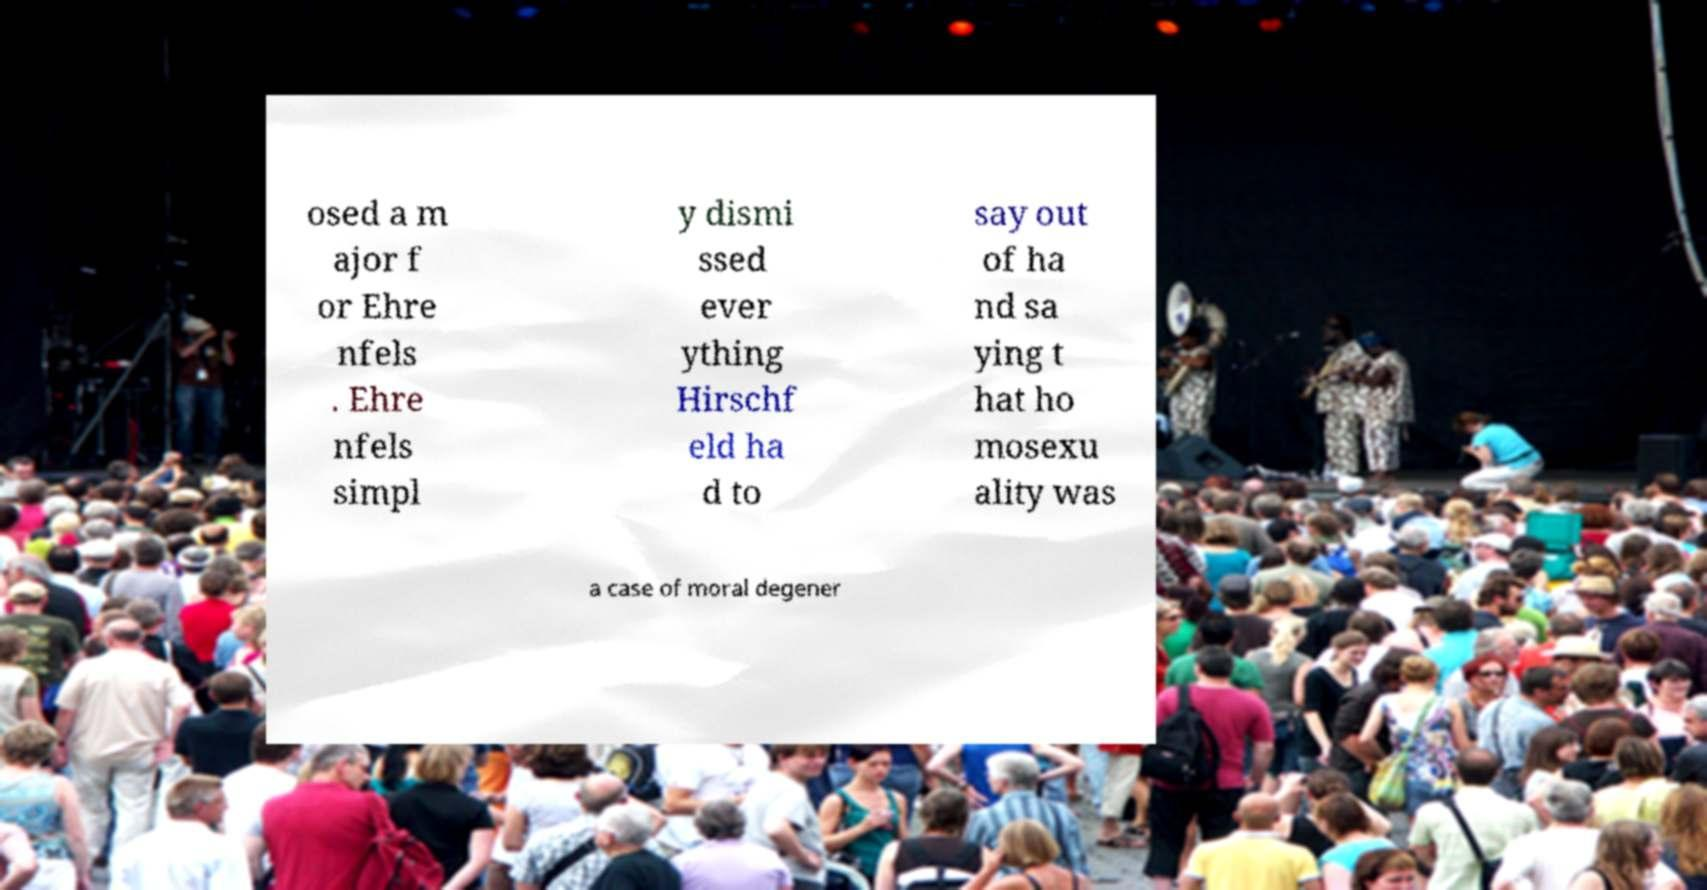I need the written content from this picture converted into text. Can you do that? osed a m ajor f or Ehre nfels . Ehre nfels simpl y dismi ssed ever ything Hirschf eld ha d to say out of ha nd sa ying t hat ho mosexu ality was a case of moral degener 